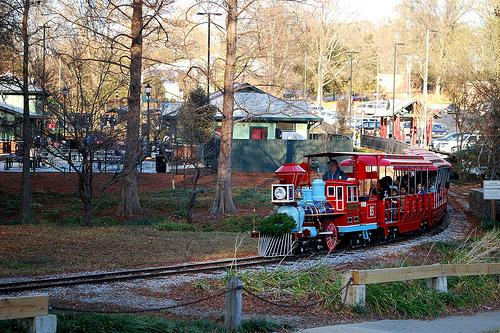Question: what is this vehicle?
Choices:
A. A train.
B. A bus.
C. A car.
D. A truck.
Answer with the letter. Answer: A Question: what is powering the train?
Choices:
A. Steam.
B. The engine.
C. Electricity.
D. Fuel.
Answer with the letter. Answer: B Question: why are the people riding the train?
Choices:
A. To travel.
B. To reach their destination.
C. For the experience.
D. For a tour.
Answer with the letter. Answer: D Question: who is riding the train?
Choices:
A. Professionals.
B. Passengers.
C. Commuters.
D. Tourists.
Answer with the letter. Answer: B Question: when was this photo taken?
Choices:
A. During the day.
B. Afternoon.
C. Morning.
D. Early evening.
Answer with the letter. Answer: A 